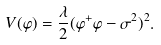<formula> <loc_0><loc_0><loc_500><loc_500>V ( \varphi ) = \frac { \lambda } { 2 } ( \varphi ^ { + } \varphi - \sigma ^ { 2 } ) ^ { 2 } .</formula> 